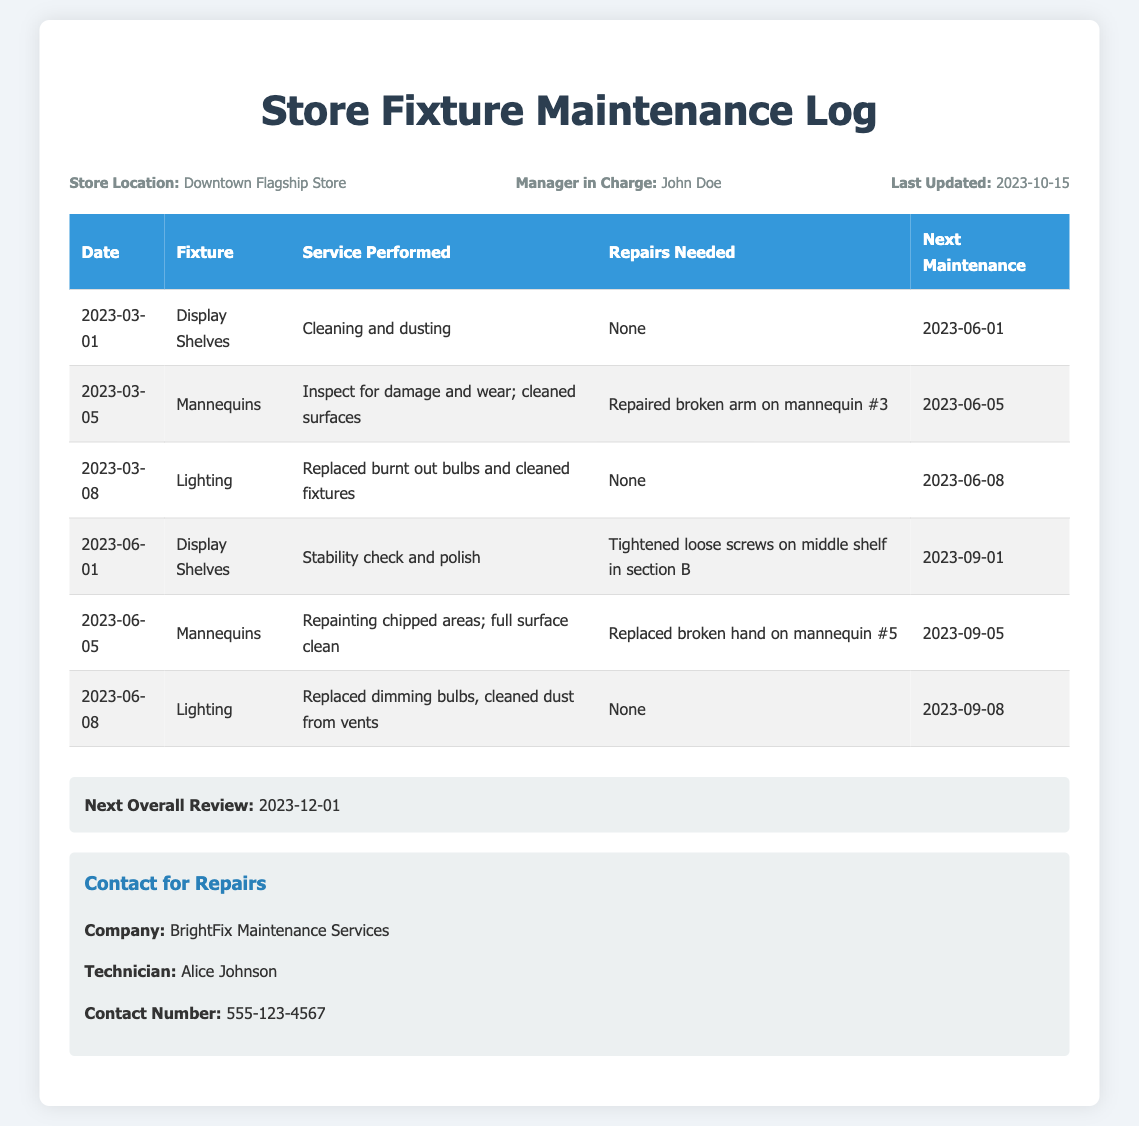What is the store location? The store location is mentioned in the header section of the document.
Answer: Downtown Flagship Store Who is the manager in charge? The manager in charge is listed in the header section of the document.
Answer: John Doe What is the date of the last update? The date of the last update is provided in the header info.
Answer: 2023-10-15 What service was performed on the display shelves on March 1, 2023? The service performed is recorded in the maintenance log table for the display shelves.
Answer: Cleaning and dusting What repairs were needed for mannequin #3? The repairs needed are detailed in the maintenance log under the service performed for mannequins.
Answer: Repaired broken arm on mannequin #3 When is the next maintenance due for the lighting? The next maintenance date is noted in the maintenance log table for the lighting fixture.
Answer: 2023-09-08 What is the next overall review date? The next overall review date is mentioned towards the bottom of the document.
Answer: 2023-12-01 Who can be contacted for repairs? The contact information for repairs is found in the contact info section of the document.
Answer: BrightFix Maintenance Services What was done during the last maintenance for mannequins on June 5, 2023? The maintenance activity is described in the maintenance log for mannequins.
Answer: Repainting chipped areas; full surface clean 